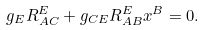<formula> <loc_0><loc_0><loc_500><loc_500>g _ { E } R _ { A C } ^ { E } + g _ { C E } R _ { A B } ^ { E } x ^ { B } = 0 .</formula> 